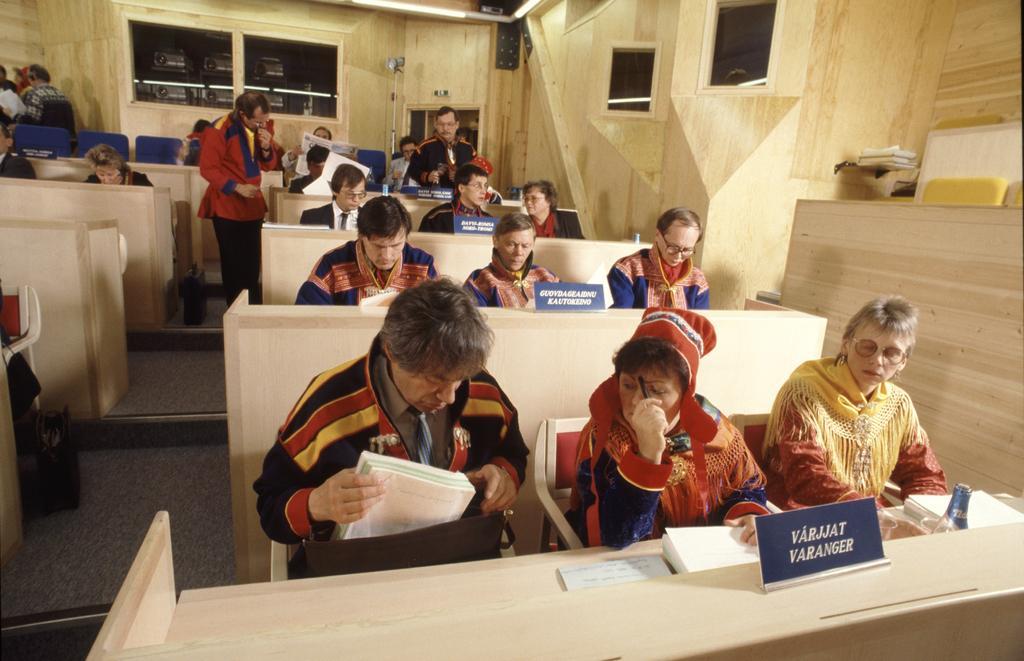Can you describe this image briefly? In this image i can see there are group of people are sitting on a chair in front of a desk. I can also see there is a man who is standing on a floor. 